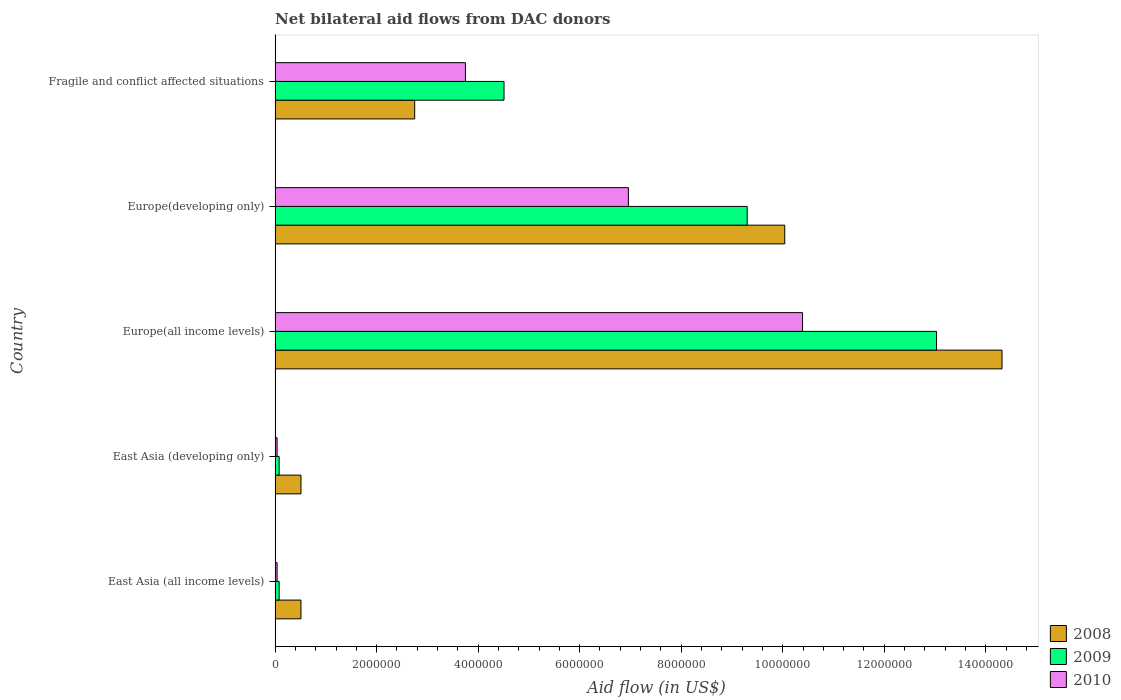How many groups of bars are there?
Keep it short and to the point. 5. Are the number of bars on each tick of the Y-axis equal?
Offer a terse response. Yes. How many bars are there on the 2nd tick from the top?
Make the answer very short. 3. What is the label of the 4th group of bars from the top?
Give a very brief answer. East Asia (developing only). In how many cases, is the number of bars for a given country not equal to the number of legend labels?
Your response must be concise. 0. What is the net bilateral aid flow in 2010 in East Asia (all income levels)?
Your response must be concise. 4.00e+04. Across all countries, what is the maximum net bilateral aid flow in 2008?
Your response must be concise. 1.43e+07. Across all countries, what is the minimum net bilateral aid flow in 2010?
Offer a very short reply. 4.00e+04. In which country was the net bilateral aid flow in 2008 maximum?
Your response must be concise. Europe(all income levels). In which country was the net bilateral aid flow in 2008 minimum?
Your answer should be compact. East Asia (all income levels). What is the total net bilateral aid flow in 2008 in the graph?
Keep it short and to the point. 2.81e+07. What is the difference between the net bilateral aid flow in 2010 in Europe(all income levels) and that in Fragile and conflict affected situations?
Your response must be concise. 6.64e+06. What is the difference between the net bilateral aid flow in 2008 in East Asia (all income levels) and the net bilateral aid flow in 2010 in East Asia (developing only)?
Give a very brief answer. 4.70e+05. What is the average net bilateral aid flow in 2009 per country?
Give a very brief answer. 5.40e+06. What is the difference between the net bilateral aid flow in 2008 and net bilateral aid flow in 2010 in Europe(all income levels)?
Your response must be concise. 3.93e+06. In how many countries, is the net bilateral aid flow in 2008 greater than 3600000 US$?
Ensure brevity in your answer.  2. Is the net bilateral aid flow in 2008 in East Asia (all income levels) less than that in Europe(all income levels)?
Offer a very short reply. Yes. Is the difference between the net bilateral aid flow in 2008 in East Asia (developing only) and Europe(developing only) greater than the difference between the net bilateral aid flow in 2010 in East Asia (developing only) and Europe(developing only)?
Offer a terse response. No. What is the difference between the highest and the second highest net bilateral aid flow in 2009?
Your response must be concise. 3.73e+06. What is the difference between the highest and the lowest net bilateral aid flow in 2009?
Your answer should be compact. 1.30e+07. Is the sum of the net bilateral aid flow in 2008 in East Asia (developing only) and Fragile and conflict affected situations greater than the maximum net bilateral aid flow in 2009 across all countries?
Provide a short and direct response. No. What does the 2nd bar from the top in East Asia (developing only) represents?
Offer a very short reply. 2009. Is it the case that in every country, the sum of the net bilateral aid flow in 2008 and net bilateral aid flow in 2009 is greater than the net bilateral aid flow in 2010?
Your answer should be compact. Yes. How many bars are there?
Ensure brevity in your answer.  15. Are all the bars in the graph horizontal?
Offer a terse response. Yes. How many countries are there in the graph?
Offer a very short reply. 5. What is the difference between two consecutive major ticks on the X-axis?
Give a very brief answer. 2.00e+06. Does the graph contain any zero values?
Keep it short and to the point. No. Does the graph contain grids?
Make the answer very short. No. How are the legend labels stacked?
Give a very brief answer. Vertical. What is the title of the graph?
Provide a succinct answer. Net bilateral aid flows from DAC donors. Does "2000" appear as one of the legend labels in the graph?
Provide a succinct answer. No. What is the label or title of the X-axis?
Your answer should be very brief. Aid flow (in US$). What is the label or title of the Y-axis?
Your response must be concise. Country. What is the Aid flow (in US$) in 2008 in East Asia (all income levels)?
Make the answer very short. 5.10e+05. What is the Aid flow (in US$) in 2009 in East Asia (all income levels)?
Provide a succinct answer. 8.00e+04. What is the Aid flow (in US$) in 2008 in East Asia (developing only)?
Give a very brief answer. 5.10e+05. What is the Aid flow (in US$) in 2009 in East Asia (developing only)?
Provide a succinct answer. 8.00e+04. What is the Aid flow (in US$) of 2010 in East Asia (developing only)?
Offer a very short reply. 4.00e+04. What is the Aid flow (in US$) in 2008 in Europe(all income levels)?
Offer a terse response. 1.43e+07. What is the Aid flow (in US$) of 2009 in Europe(all income levels)?
Offer a terse response. 1.30e+07. What is the Aid flow (in US$) in 2010 in Europe(all income levels)?
Your response must be concise. 1.04e+07. What is the Aid flow (in US$) of 2008 in Europe(developing only)?
Give a very brief answer. 1.00e+07. What is the Aid flow (in US$) of 2009 in Europe(developing only)?
Make the answer very short. 9.30e+06. What is the Aid flow (in US$) of 2010 in Europe(developing only)?
Offer a terse response. 6.96e+06. What is the Aid flow (in US$) of 2008 in Fragile and conflict affected situations?
Offer a very short reply. 2.75e+06. What is the Aid flow (in US$) of 2009 in Fragile and conflict affected situations?
Ensure brevity in your answer.  4.51e+06. What is the Aid flow (in US$) in 2010 in Fragile and conflict affected situations?
Make the answer very short. 3.75e+06. Across all countries, what is the maximum Aid flow (in US$) of 2008?
Your answer should be very brief. 1.43e+07. Across all countries, what is the maximum Aid flow (in US$) in 2009?
Ensure brevity in your answer.  1.30e+07. Across all countries, what is the maximum Aid flow (in US$) of 2010?
Ensure brevity in your answer.  1.04e+07. Across all countries, what is the minimum Aid flow (in US$) in 2008?
Keep it short and to the point. 5.10e+05. Across all countries, what is the minimum Aid flow (in US$) in 2009?
Your answer should be very brief. 8.00e+04. Across all countries, what is the minimum Aid flow (in US$) of 2010?
Provide a short and direct response. 4.00e+04. What is the total Aid flow (in US$) in 2008 in the graph?
Offer a terse response. 2.81e+07. What is the total Aid flow (in US$) of 2009 in the graph?
Give a very brief answer. 2.70e+07. What is the total Aid flow (in US$) of 2010 in the graph?
Offer a terse response. 2.12e+07. What is the difference between the Aid flow (in US$) of 2009 in East Asia (all income levels) and that in East Asia (developing only)?
Provide a short and direct response. 0. What is the difference between the Aid flow (in US$) of 2008 in East Asia (all income levels) and that in Europe(all income levels)?
Make the answer very short. -1.38e+07. What is the difference between the Aid flow (in US$) in 2009 in East Asia (all income levels) and that in Europe(all income levels)?
Offer a very short reply. -1.30e+07. What is the difference between the Aid flow (in US$) of 2010 in East Asia (all income levels) and that in Europe(all income levels)?
Give a very brief answer. -1.04e+07. What is the difference between the Aid flow (in US$) of 2008 in East Asia (all income levels) and that in Europe(developing only)?
Make the answer very short. -9.53e+06. What is the difference between the Aid flow (in US$) of 2009 in East Asia (all income levels) and that in Europe(developing only)?
Keep it short and to the point. -9.22e+06. What is the difference between the Aid flow (in US$) of 2010 in East Asia (all income levels) and that in Europe(developing only)?
Provide a succinct answer. -6.92e+06. What is the difference between the Aid flow (in US$) in 2008 in East Asia (all income levels) and that in Fragile and conflict affected situations?
Your response must be concise. -2.24e+06. What is the difference between the Aid flow (in US$) of 2009 in East Asia (all income levels) and that in Fragile and conflict affected situations?
Offer a terse response. -4.43e+06. What is the difference between the Aid flow (in US$) of 2010 in East Asia (all income levels) and that in Fragile and conflict affected situations?
Your answer should be very brief. -3.71e+06. What is the difference between the Aid flow (in US$) in 2008 in East Asia (developing only) and that in Europe(all income levels)?
Your response must be concise. -1.38e+07. What is the difference between the Aid flow (in US$) in 2009 in East Asia (developing only) and that in Europe(all income levels)?
Provide a succinct answer. -1.30e+07. What is the difference between the Aid flow (in US$) of 2010 in East Asia (developing only) and that in Europe(all income levels)?
Make the answer very short. -1.04e+07. What is the difference between the Aid flow (in US$) in 2008 in East Asia (developing only) and that in Europe(developing only)?
Make the answer very short. -9.53e+06. What is the difference between the Aid flow (in US$) in 2009 in East Asia (developing only) and that in Europe(developing only)?
Ensure brevity in your answer.  -9.22e+06. What is the difference between the Aid flow (in US$) of 2010 in East Asia (developing only) and that in Europe(developing only)?
Your answer should be compact. -6.92e+06. What is the difference between the Aid flow (in US$) of 2008 in East Asia (developing only) and that in Fragile and conflict affected situations?
Your answer should be compact. -2.24e+06. What is the difference between the Aid flow (in US$) in 2009 in East Asia (developing only) and that in Fragile and conflict affected situations?
Offer a terse response. -4.43e+06. What is the difference between the Aid flow (in US$) in 2010 in East Asia (developing only) and that in Fragile and conflict affected situations?
Offer a very short reply. -3.71e+06. What is the difference between the Aid flow (in US$) in 2008 in Europe(all income levels) and that in Europe(developing only)?
Provide a short and direct response. 4.28e+06. What is the difference between the Aid flow (in US$) of 2009 in Europe(all income levels) and that in Europe(developing only)?
Your answer should be very brief. 3.73e+06. What is the difference between the Aid flow (in US$) in 2010 in Europe(all income levels) and that in Europe(developing only)?
Keep it short and to the point. 3.43e+06. What is the difference between the Aid flow (in US$) of 2008 in Europe(all income levels) and that in Fragile and conflict affected situations?
Make the answer very short. 1.16e+07. What is the difference between the Aid flow (in US$) in 2009 in Europe(all income levels) and that in Fragile and conflict affected situations?
Offer a terse response. 8.52e+06. What is the difference between the Aid flow (in US$) in 2010 in Europe(all income levels) and that in Fragile and conflict affected situations?
Your response must be concise. 6.64e+06. What is the difference between the Aid flow (in US$) of 2008 in Europe(developing only) and that in Fragile and conflict affected situations?
Keep it short and to the point. 7.29e+06. What is the difference between the Aid flow (in US$) in 2009 in Europe(developing only) and that in Fragile and conflict affected situations?
Make the answer very short. 4.79e+06. What is the difference between the Aid flow (in US$) of 2010 in Europe(developing only) and that in Fragile and conflict affected situations?
Your answer should be compact. 3.21e+06. What is the difference between the Aid flow (in US$) in 2008 in East Asia (all income levels) and the Aid flow (in US$) in 2010 in East Asia (developing only)?
Your answer should be very brief. 4.70e+05. What is the difference between the Aid flow (in US$) of 2008 in East Asia (all income levels) and the Aid flow (in US$) of 2009 in Europe(all income levels)?
Provide a short and direct response. -1.25e+07. What is the difference between the Aid flow (in US$) in 2008 in East Asia (all income levels) and the Aid flow (in US$) in 2010 in Europe(all income levels)?
Provide a succinct answer. -9.88e+06. What is the difference between the Aid flow (in US$) of 2009 in East Asia (all income levels) and the Aid flow (in US$) of 2010 in Europe(all income levels)?
Offer a terse response. -1.03e+07. What is the difference between the Aid flow (in US$) in 2008 in East Asia (all income levels) and the Aid flow (in US$) in 2009 in Europe(developing only)?
Your answer should be compact. -8.79e+06. What is the difference between the Aid flow (in US$) of 2008 in East Asia (all income levels) and the Aid flow (in US$) of 2010 in Europe(developing only)?
Ensure brevity in your answer.  -6.45e+06. What is the difference between the Aid flow (in US$) in 2009 in East Asia (all income levels) and the Aid flow (in US$) in 2010 in Europe(developing only)?
Your answer should be very brief. -6.88e+06. What is the difference between the Aid flow (in US$) in 2008 in East Asia (all income levels) and the Aid flow (in US$) in 2009 in Fragile and conflict affected situations?
Give a very brief answer. -4.00e+06. What is the difference between the Aid flow (in US$) of 2008 in East Asia (all income levels) and the Aid flow (in US$) of 2010 in Fragile and conflict affected situations?
Your answer should be compact. -3.24e+06. What is the difference between the Aid flow (in US$) in 2009 in East Asia (all income levels) and the Aid flow (in US$) in 2010 in Fragile and conflict affected situations?
Give a very brief answer. -3.67e+06. What is the difference between the Aid flow (in US$) in 2008 in East Asia (developing only) and the Aid flow (in US$) in 2009 in Europe(all income levels)?
Offer a very short reply. -1.25e+07. What is the difference between the Aid flow (in US$) in 2008 in East Asia (developing only) and the Aid flow (in US$) in 2010 in Europe(all income levels)?
Offer a terse response. -9.88e+06. What is the difference between the Aid flow (in US$) in 2009 in East Asia (developing only) and the Aid flow (in US$) in 2010 in Europe(all income levels)?
Make the answer very short. -1.03e+07. What is the difference between the Aid flow (in US$) of 2008 in East Asia (developing only) and the Aid flow (in US$) of 2009 in Europe(developing only)?
Your answer should be very brief. -8.79e+06. What is the difference between the Aid flow (in US$) in 2008 in East Asia (developing only) and the Aid flow (in US$) in 2010 in Europe(developing only)?
Your answer should be compact. -6.45e+06. What is the difference between the Aid flow (in US$) of 2009 in East Asia (developing only) and the Aid flow (in US$) of 2010 in Europe(developing only)?
Give a very brief answer. -6.88e+06. What is the difference between the Aid flow (in US$) of 2008 in East Asia (developing only) and the Aid flow (in US$) of 2009 in Fragile and conflict affected situations?
Provide a succinct answer. -4.00e+06. What is the difference between the Aid flow (in US$) in 2008 in East Asia (developing only) and the Aid flow (in US$) in 2010 in Fragile and conflict affected situations?
Your response must be concise. -3.24e+06. What is the difference between the Aid flow (in US$) in 2009 in East Asia (developing only) and the Aid flow (in US$) in 2010 in Fragile and conflict affected situations?
Make the answer very short. -3.67e+06. What is the difference between the Aid flow (in US$) of 2008 in Europe(all income levels) and the Aid flow (in US$) of 2009 in Europe(developing only)?
Offer a very short reply. 5.02e+06. What is the difference between the Aid flow (in US$) of 2008 in Europe(all income levels) and the Aid flow (in US$) of 2010 in Europe(developing only)?
Make the answer very short. 7.36e+06. What is the difference between the Aid flow (in US$) in 2009 in Europe(all income levels) and the Aid flow (in US$) in 2010 in Europe(developing only)?
Ensure brevity in your answer.  6.07e+06. What is the difference between the Aid flow (in US$) in 2008 in Europe(all income levels) and the Aid flow (in US$) in 2009 in Fragile and conflict affected situations?
Ensure brevity in your answer.  9.81e+06. What is the difference between the Aid flow (in US$) in 2008 in Europe(all income levels) and the Aid flow (in US$) in 2010 in Fragile and conflict affected situations?
Your response must be concise. 1.06e+07. What is the difference between the Aid flow (in US$) in 2009 in Europe(all income levels) and the Aid flow (in US$) in 2010 in Fragile and conflict affected situations?
Ensure brevity in your answer.  9.28e+06. What is the difference between the Aid flow (in US$) of 2008 in Europe(developing only) and the Aid flow (in US$) of 2009 in Fragile and conflict affected situations?
Offer a very short reply. 5.53e+06. What is the difference between the Aid flow (in US$) in 2008 in Europe(developing only) and the Aid flow (in US$) in 2010 in Fragile and conflict affected situations?
Offer a very short reply. 6.29e+06. What is the difference between the Aid flow (in US$) in 2009 in Europe(developing only) and the Aid flow (in US$) in 2010 in Fragile and conflict affected situations?
Ensure brevity in your answer.  5.55e+06. What is the average Aid flow (in US$) of 2008 per country?
Ensure brevity in your answer.  5.63e+06. What is the average Aid flow (in US$) in 2009 per country?
Ensure brevity in your answer.  5.40e+06. What is the average Aid flow (in US$) in 2010 per country?
Provide a succinct answer. 4.24e+06. What is the difference between the Aid flow (in US$) in 2008 and Aid flow (in US$) in 2009 in East Asia (all income levels)?
Offer a terse response. 4.30e+05. What is the difference between the Aid flow (in US$) in 2008 and Aid flow (in US$) in 2010 in East Asia (all income levels)?
Make the answer very short. 4.70e+05. What is the difference between the Aid flow (in US$) in 2009 and Aid flow (in US$) in 2010 in East Asia (all income levels)?
Your answer should be very brief. 4.00e+04. What is the difference between the Aid flow (in US$) of 2008 and Aid flow (in US$) of 2009 in Europe(all income levels)?
Your answer should be very brief. 1.29e+06. What is the difference between the Aid flow (in US$) of 2008 and Aid flow (in US$) of 2010 in Europe(all income levels)?
Offer a terse response. 3.93e+06. What is the difference between the Aid flow (in US$) in 2009 and Aid flow (in US$) in 2010 in Europe(all income levels)?
Provide a succinct answer. 2.64e+06. What is the difference between the Aid flow (in US$) in 2008 and Aid flow (in US$) in 2009 in Europe(developing only)?
Ensure brevity in your answer.  7.40e+05. What is the difference between the Aid flow (in US$) in 2008 and Aid flow (in US$) in 2010 in Europe(developing only)?
Your answer should be compact. 3.08e+06. What is the difference between the Aid flow (in US$) in 2009 and Aid flow (in US$) in 2010 in Europe(developing only)?
Offer a very short reply. 2.34e+06. What is the difference between the Aid flow (in US$) of 2008 and Aid flow (in US$) of 2009 in Fragile and conflict affected situations?
Offer a terse response. -1.76e+06. What is the difference between the Aid flow (in US$) in 2008 and Aid flow (in US$) in 2010 in Fragile and conflict affected situations?
Offer a very short reply. -1.00e+06. What is the difference between the Aid flow (in US$) of 2009 and Aid flow (in US$) of 2010 in Fragile and conflict affected situations?
Offer a very short reply. 7.60e+05. What is the ratio of the Aid flow (in US$) of 2008 in East Asia (all income levels) to that in East Asia (developing only)?
Your response must be concise. 1. What is the ratio of the Aid flow (in US$) of 2009 in East Asia (all income levels) to that in East Asia (developing only)?
Make the answer very short. 1. What is the ratio of the Aid flow (in US$) in 2008 in East Asia (all income levels) to that in Europe(all income levels)?
Your response must be concise. 0.04. What is the ratio of the Aid flow (in US$) in 2009 in East Asia (all income levels) to that in Europe(all income levels)?
Your answer should be very brief. 0.01. What is the ratio of the Aid flow (in US$) in 2010 in East Asia (all income levels) to that in Europe(all income levels)?
Your response must be concise. 0. What is the ratio of the Aid flow (in US$) of 2008 in East Asia (all income levels) to that in Europe(developing only)?
Offer a very short reply. 0.05. What is the ratio of the Aid flow (in US$) of 2009 in East Asia (all income levels) to that in Europe(developing only)?
Keep it short and to the point. 0.01. What is the ratio of the Aid flow (in US$) in 2010 in East Asia (all income levels) to that in Europe(developing only)?
Your answer should be very brief. 0.01. What is the ratio of the Aid flow (in US$) in 2008 in East Asia (all income levels) to that in Fragile and conflict affected situations?
Your answer should be compact. 0.19. What is the ratio of the Aid flow (in US$) in 2009 in East Asia (all income levels) to that in Fragile and conflict affected situations?
Your answer should be very brief. 0.02. What is the ratio of the Aid flow (in US$) in 2010 in East Asia (all income levels) to that in Fragile and conflict affected situations?
Give a very brief answer. 0.01. What is the ratio of the Aid flow (in US$) of 2008 in East Asia (developing only) to that in Europe(all income levels)?
Ensure brevity in your answer.  0.04. What is the ratio of the Aid flow (in US$) in 2009 in East Asia (developing only) to that in Europe(all income levels)?
Give a very brief answer. 0.01. What is the ratio of the Aid flow (in US$) in 2010 in East Asia (developing only) to that in Europe(all income levels)?
Keep it short and to the point. 0. What is the ratio of the Aid flow (in US$) in 2008 in East Asia (developing only) to that in Europe(developing only)?
Make the answer very short. 0.05. What is the ratio of the Aid flow (in US$) of 2009 in East Asia (developing only) to that in Europe(developing only)?
Make the answer very short. 0.01. What is the ratio of the Aid flow (in US$) in 2010 in East Asia (developing only) to that in Europe(developing only)?
Offer a very short reply. 0.01. What is the ratio of the Aid flow (in US$) of 2008 in East Asia (developing only) to that in Fragile and conflict affected situations?
Provide a short and direct response. 0.19. What is the ratio of the Aid flow (in US$) of 2009 in East Asia (developing only) to that in Fragile and conflict affected situations?
Your answer should be compact. 0.02. What is the ratio of the Aid flow (in US$) of 2010 in East Asia (developing only) to that in Fragile and conflict affected situations?
Your response must be concise. 0.01. What is the ratio of the Aid flow (in US$) in 2008 in Europe(all income levels) to that in Europe(developing only)?
Make the answer very short. 1.43. What is the ratio of the Aid flow (in US$) in 2009 in Europe(all income levels) to that in Europe(developing only)?
Ensure brevity in your answer.  1.4. What is the ratio of the Aid flow (in US$) of 2010 in Europe(all income levels) to that in Europe(developing only)?
Offer a terse response. 1.49. What is the ratio of the Aid flow (in US$) in 2008 in Europe(all income levels) to that in Fragile and conflict affected situations?
Make the answer very short. 5.21. What is the ratio of the Aid flow (in US$) in 2009 in Europe(all income levels) to that in Fragile and conflict affected situations?
Your answer should be very brief. 2.89. What is the ratio of the Aid flow (in US$) in 2010 in Europe(all income levels) to that in Fragile and conflict affected situations?
Keep it short and to the point. 2.77. What is the ratio of the Aid flow (in US$) of 2008 in Europe(developing only) to that in Fragile and conflict affected situations?
Your answer should be compact. 3.65. What is the ratio of the Aid flow (in US$) in 2009 in Europe(developing only) to that in Fragile and conflict affected situations?
Your answer should be compact. 2.06. What is the ratio of the Aid flow (in US$) in 2010 in Europe(developing only) to that in Fragile and conflict affected situations?
Offer a terse response. 1.86. What is the difference between the highest and the second highest Aid flow (in US$) in 2008?
Your answer should be compact. 4.28e+06. What is the difference between the highest and the second highest Aid flow (in US$) of 2009?
Make the answer very short. 3.73e+06. What is the difference between the highest and the second highest Aid flow (in US$) in 2010?
Keep it short and to the point. 3.43e+06. What is the difference between the highest and the lowest Aid flow (in US$) in 2008?
Give a very brief answer. 1.38e+07. What is the difference between the highest and the lowest Aid flow (in US$) of 2009?
Provide a succinct answer. 1.30e+07. What is the difference between the highest and the lowest Aid flow (in US$) of 2010?
Offer a terse response. 1.04e+07. 